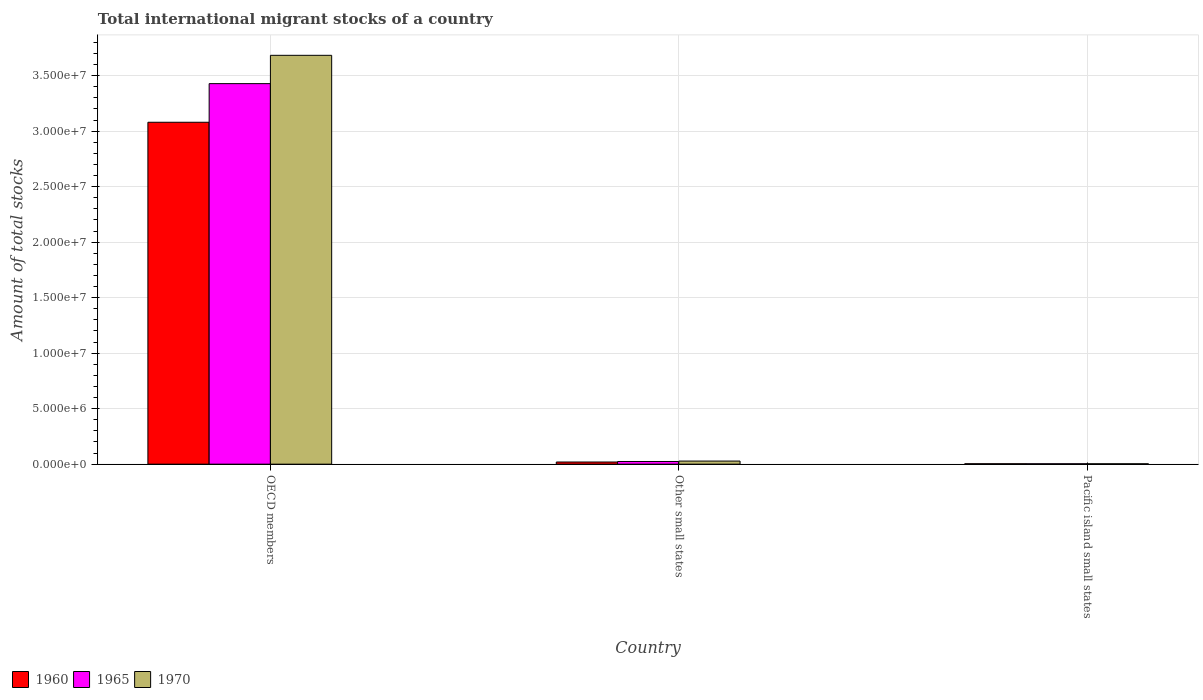How many different coloured bars are there?
Offer a very short reply. 3. How many groups of bars are there?
Give a very brief answer. 3. Are the number of bars per tick equal to the number of legend labels?
Your answer should be very brief. Yes. Are the number of bars on each tick of the X-axis equal?
Keep it short and to the point. Yes. How many bars are there on the 2nd tick from the left?
Offer a terse response. 3. How many bars are there on the 2nd tick from the right?
Provide a short and direct response. 3. What is the label of the 2nd group of bars from the left?
Give a very brief answer. Other small states. What is the amount of total stocks in in 1970 in Pacific island small states?
Provide a short and direct response. 3.53e+04. Across all countries, what is the maximum amount of total stocks in in 1960?
Make the answer very short. 3.08e+07. Across all countries, what is the minimum amount of total stocks in in 1970?
Provide a succinct answer. 3.53e+04. In which country was the amount of total stocks in in 1965 maximum?
Offer a very short reply. OECD members. In which country was the amount of total stocks in in 1965 minimum?
Ensure brevity in your answer.  Pacific island small states. What is the total amount of total stocks in in 1960 in the graph?
Your response must be concise. 3.10e+07. What is the difference between the amount of total stocks in in 1960 in OECD members and that in Pacific island small states?
Give a very brief answer. 3.08e+07. What is the difference between the amount of total stocks in in 1970 in Pacific island small states and the amount of total stocks in in 1965 in Other small states?
Offer a very short reply. -2.05e+05. What is the average amount of total stocks in in 1960 per country?
Ensure brevity in your answer.  1.03e+07. What is the difference between the amount of total stocks in of/in 1960 and amount of total stocks in of/in 1965 in Other small states?
Provide a short and direct response. -4.56e+04. In how many countries, is the amount of total stocks in in 1970 greater than 25000000?
Your answer should be very brief. 1. What is the ratio of the amount of total stocks in in 1965 in OECD members to that in Pacific island small states?
Provide a succinct answer. 941.3. Is the difference between the amount of total stocks in in 1960 in OECD members and Pacific island small states greater than the difference between the amount of total stocks in in 1965 in OECD members and Pacific island small states?
Offer a very short reply. No. What is the difference between the highest and the second highest amount of total stocks in in 1970?
Provide a succinct answer. -3.66e+07. What is the difference between the highest and the lowest amount of total stocks in in 1960?
Give a very brief answer. 3.08e+07. Is the sum of the amount of total stocks in in 1960 in Other small states and Pacific island small states greater than the maximum amount of total stocks in in 1965 across all countries?
Your answer should be very brief. No. What does the 2nd bar from the left in Pacific island small states represents?
Offer a terse response. 1965. What does the 2nd bar from the right in Other small states represents?
Your answer should be very brief. 1965. Is it the case that in every country, the sum of the amount of total stocks in in 1960 and amount of total stocks in in 1965 is greater than the amount of total stocks in in 1970?
Ensure brevity in your answer.  Yes. Are all the bars in the graph horizontal?
Offer a very short reply. No. Are the values on the major ticks of Y-axis written in scientific E-notation?
Your answer should be compact. Yes. Does the graph contain any zero values?
Your response must be concise. No. Where does the legend appear in the graph?
Offer a terse response. Bottom left. How are the legend labels stacked?
Make the answer very short. Horizontal. What is the title of the graph?
Your response must be concise. Total international migrant stocks of a country. What is the label or title of the Y-axis?
Your answer should be compact. Amount of total stocks. What is the Amount of total stocks of 1960 in OECD members?
Give a very brief answer. 3.08e+07. What is the Amount of total stocks in 1965 in OECD members?
Ensure brevity in your answer.  3.43e+07. What is the Amount of total stocks of 1970 in OECD members?
Make the answer very short. 3.68e+07. What is the Amount of total stocks in 1960 in Other small states?
Your answer should be compact. 1.95e+05. What is the Amount of total stocks in 1965 in Other small states?
Your answer should be compact. 2.41e+05. What is the Amount of total stocks of 1970 in Other small states?
Make the answer very short. 2.79e+05. What is the Amount of total stocks of 1960 in Pacific island small states?
Provide a short and direct response. 3.82e+04. What is the Amount of total stocks of 1965 in Pacific island small states?
Ensure brevity in your answer.  3.64e+04. What is the Amount of total stocks of 1970 in Pacific island small states?
Make the answer very short. 3.53e+04. Across all countries, what is the maximum Amount of total stocks of 1960?
Your answer should be compact. 3.08e+07. Across all countries, what is the maximum Amount of total stocks in 1965?
Provide a succinct answer. 3.43e+07. Across all countries, what is the maximum Amount of total stocks in 1970?
Keep it short and to the point. 3.68e+07. Across all countries, what is the minimum Amount of total stocks of 1960?
Provide a succinct answer. 3.82e+04. Across all countries, what is the minimum Amount of total stocks in 1965?
Provide a short and direct response. 3.64e+04. Across all countries, what is the minimum Amount of total stocks of 1970?
Your answer should be very brief. 3.53e+04. What is the total Amount of total stocks of 1960 in the graph?
Your response must be concise. 3.10e+07. What is the total Amount of total stocks in 1965 in the graph?
Your answer should be compact. 3.46e+07. What is the total Amount of total stocks in 1970 in the graph?
Provide a succinct answer. 3.71e+07. What is the difference between the Amount of total stocks of 1960 in OECD members and that in Other small states?
Provide a short and direct response. 3.06e+07. What is the difference between the Amount of total stocks in 1965 in OECD members and that in Other small states?
Your answer should be compact. 3.40e+07. What is the difference between the Amount of total stocks in 1970 in OECD members and that in Other small states?
Offer a very short reply. 3.66e+07. What is the difference between the Amount of total stocks of 1960 in OECD members and that in Pacific island small states?
Provide a succinct answer. 3.08e+07. What is the difference between the Amount of total stocks of 1965 in OECD members and that in Pacific island small states?
Your response must be concise. 3.42e+07. What is the difference between the Amount of total stocks in 1970 in OECD members and that in Pacific island small states?
Make the answer very short. 3.68e+07. What is the difference between the Amount of total stocks of 1960 in Other small states and that in Pacific island small states?
Ensure brevity in your answer.  1.57e+05. What is the difference between the Amount of total stocks of 1965 in Other small states and that in Pacific island small states?
Offer a terse response. 2.04e+05. What is the difference between the Amount of total stocks in 1970 in Other small states and that in Pacific island small states?
Your answer should be compact. 2.44e+05. What is the difference between the Amount of total stocks of 1960 in OECD members and the Amount of total stocks of 1965 in Other small states?
Offer a terse response. 3.06e+07. What is the difference between the Amount of total stocks in 1960 in OECD members and the Amount of total stocks in 1970 in Other small states?
Make the answer very short. 3.05e+07. What is the difference between the Amount of total stocks of 1965 in OECD members and the Amount of total stocks of 1970 in Other small states?
Offer a very short reply. 3.40e+07. What is the difference between the Amount of total stocks of 1960 in OECD members and the Amount of total stocks of 1965 in Pacific island small states?
Ensure brevity in your answer.  3.08e+07. What is the difference between the Amount of total stocks in 1960 in OECD members and the Amount of total stocks in 1970 in Pacific island small states?
Your response must be concise. 3.08e+07. What is the difference between the Amount of total stocks of 1965 in OECD members and the Amount of total stocks of 1970 in Pacific island small states?
Provide a short and direct response. 3.42e+07. What is the difference between the Amount of total stocks in 1960 in Other small states and the Amount of total stocks in 1965 in Pacific island small states?
Offer a very short reply. 1.58e+05. What is the difference between the Amount of total stocks of 1960 in Other small states and the Amount of total stocks of 1970 in Pacific island small states?
Keep it short and to the point. 1.60e+05. What is the difference between the Amount of total stocks of 1965 in Other small states and the Amount of total stocks of 1970 in Pacific island small states?
Offer a very short reply. 2.05e+05. What is the average Amount of total stocks in 1960 per country?
Keep it short and to the point. 1.03e+07. What is the average Amount of total stocks in 1965 per country?
Keep it short and to the point. 1.15e+07. What is the average Amount of total stocks of 1970 per country?
Your response must be concise. 1.24e+07. What is the difference between the Amount of total stocks of 1960 and Amount of total stocks of 1965 in OECD members?
Offer a terse response. -3.48e+06. What is the difference between the Amount of total stocks in 1960 and Amount of total stocks in 1970 in OECD members?
Ensure brevity in your answer.  -6.03e+06. What is the difference between the Amount of total stocks in 1965 and Amount of total stocks in 1970 in OECD members?
Give a very brief answer. -2.55e+06. What is the difference between the Amount of total stocks in 1960 and Amount of total stocks in 1965 in Other small states?
Your answer should be very brief. -4.56e+04. What is the difference between the Amount of total stocks of 1960 and Amount of total stocks of 1970 in Other small states?
Your answer should be compact. -8.40e+04. What is the difference between the Amount of total stocks of 1965 and Amount of total stocks of 1970 in Other small states?
Provide a succinct answer. -3.83e+04. What is the difference between the Amount of total stocks in 1960 and Amount of total stocks in 1965 in Pacific island small states?
Provide a succinct answer. 1751. What is the difference between the Amount of total stocks of 1960 and Amount of total stocks of 1970 in Pacific island small states?
Provide a short and direct response. 2856. What is the difference between the Amount of total stocks in 1965 and Amount of total stocks in 1970 in Pacific island small states?
Make the answer very short. 1105. What is the ratio of the Amount of total stocks in 1960 in OECD members to that in Other small states?
Provide a short and direct response. 158.07. What is the ratio of the Amount of total stocks of 1965 in OECD members to that in Other small states?
Provide a short and direct response. 142.54. What is the ratio of the Amount of total stocks of 1970 in OECD members to that in Other small states?
Offer a very short reply. 132.09. What is the ratio of the Amount of total stocks of 1960 in OECD members to that in Pacific island small states?
Your response must be concise. 806.98. What is the ratio of the Amount of total stocks in 1965 in OECD members to that in Pacific island small states?
Provide a short and direct response. 941.3. What is the ratio of the Amount of total stocks in 1970 in OECD members to that in Pacific island small states?
Your answer should be very brief. 1043.01. What is the ratio of the Amount of total stocks of 1960 in Other small states to that in Pacific island small states?
Offer a terse response. 5.11. What is the ratio of the Amount of total stocks in 1965 in Other small states to that in Pacific island small states?
Your answer should be very brief. 6.6. What is the ratio of the Amount of total stocks of 1970 in Other small states to that in Pacific island small states?
Your answer should be compact. 7.9. What is the difference between the highest and the second highest Amount of total stocks in 1960?
Make the answer very short. 3.06e+07. What is the difference between the highest and the second highest Amount of total stocks in 1965?
Provide a succinct answer. 3.40e+07. What is the difference between the highest and the second highest Amount of total stocks in 1970?
Your response must be concise. 3.66e+07. What is the difference between the highest and the lowest Amount of total stocks in 1960?
Offer a very short reply. 3.08e+07. What is the difference between the highest and the lowest Amount of total stocks of 1965?
Your answer should be compact. 3.42e+07. What is the difference between the highest and the lowest Amount of total stocks of 1970?
Keep it short and to the point. 3.68e+07. 